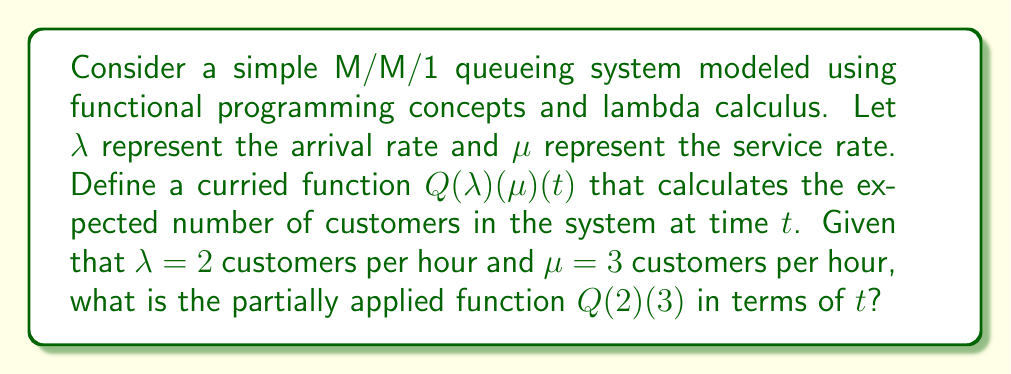Can you solve this math problem? Let's approach this step-by-step using functional programming concepts and lambda calculus:

1. In an M/M/1 queue, the expected number of customers in the system at steady state is given by:

   $$\frac{\rho}{1-\rho}$$

   where $\rho = \frac{\lambda}{\mu}$ is the traffic intensity.

2. To model the time-dependent behavior, we can use the function:

   $$N(t) = \frac{\rho}{1-\rho}(1 - e^{-(\mu-\lambda)t})$$

3. We can define our curried function $Q$ using lambda calculus:

   $$Q = \lambda \lambda. \lambda \mu. \lambda t. \frac{\frac{\lambda}{\mu}}{1-\frac{\lambda}{\mu}}(1 - e^{-(\mu-\lambda)t})$$

4. Applying the first argument $\lambda = 2$:

   $$Q(2) = \lambda \mu. \lambda t. \frac{\frac{2}{\mu}}{1-\frac{2}{\mu}}(1 - e^{-(\mu-2)t})$$

5. Applying the second argument $\mu = 3$:

   $$Q(2)(3) = \lambda t. \frac{\frac{2}{3}}{1-\frac{2}{3}}(1 - e^{-(3-2)t})$$

6. Simplifying:

   $$Q(2)(3) = \lambda t. 2(1 - e^{-t})$$

This is our final partially applied function in terms of $t$.
Answer: $\lambda t. 2(1 - e^{-t})$ 